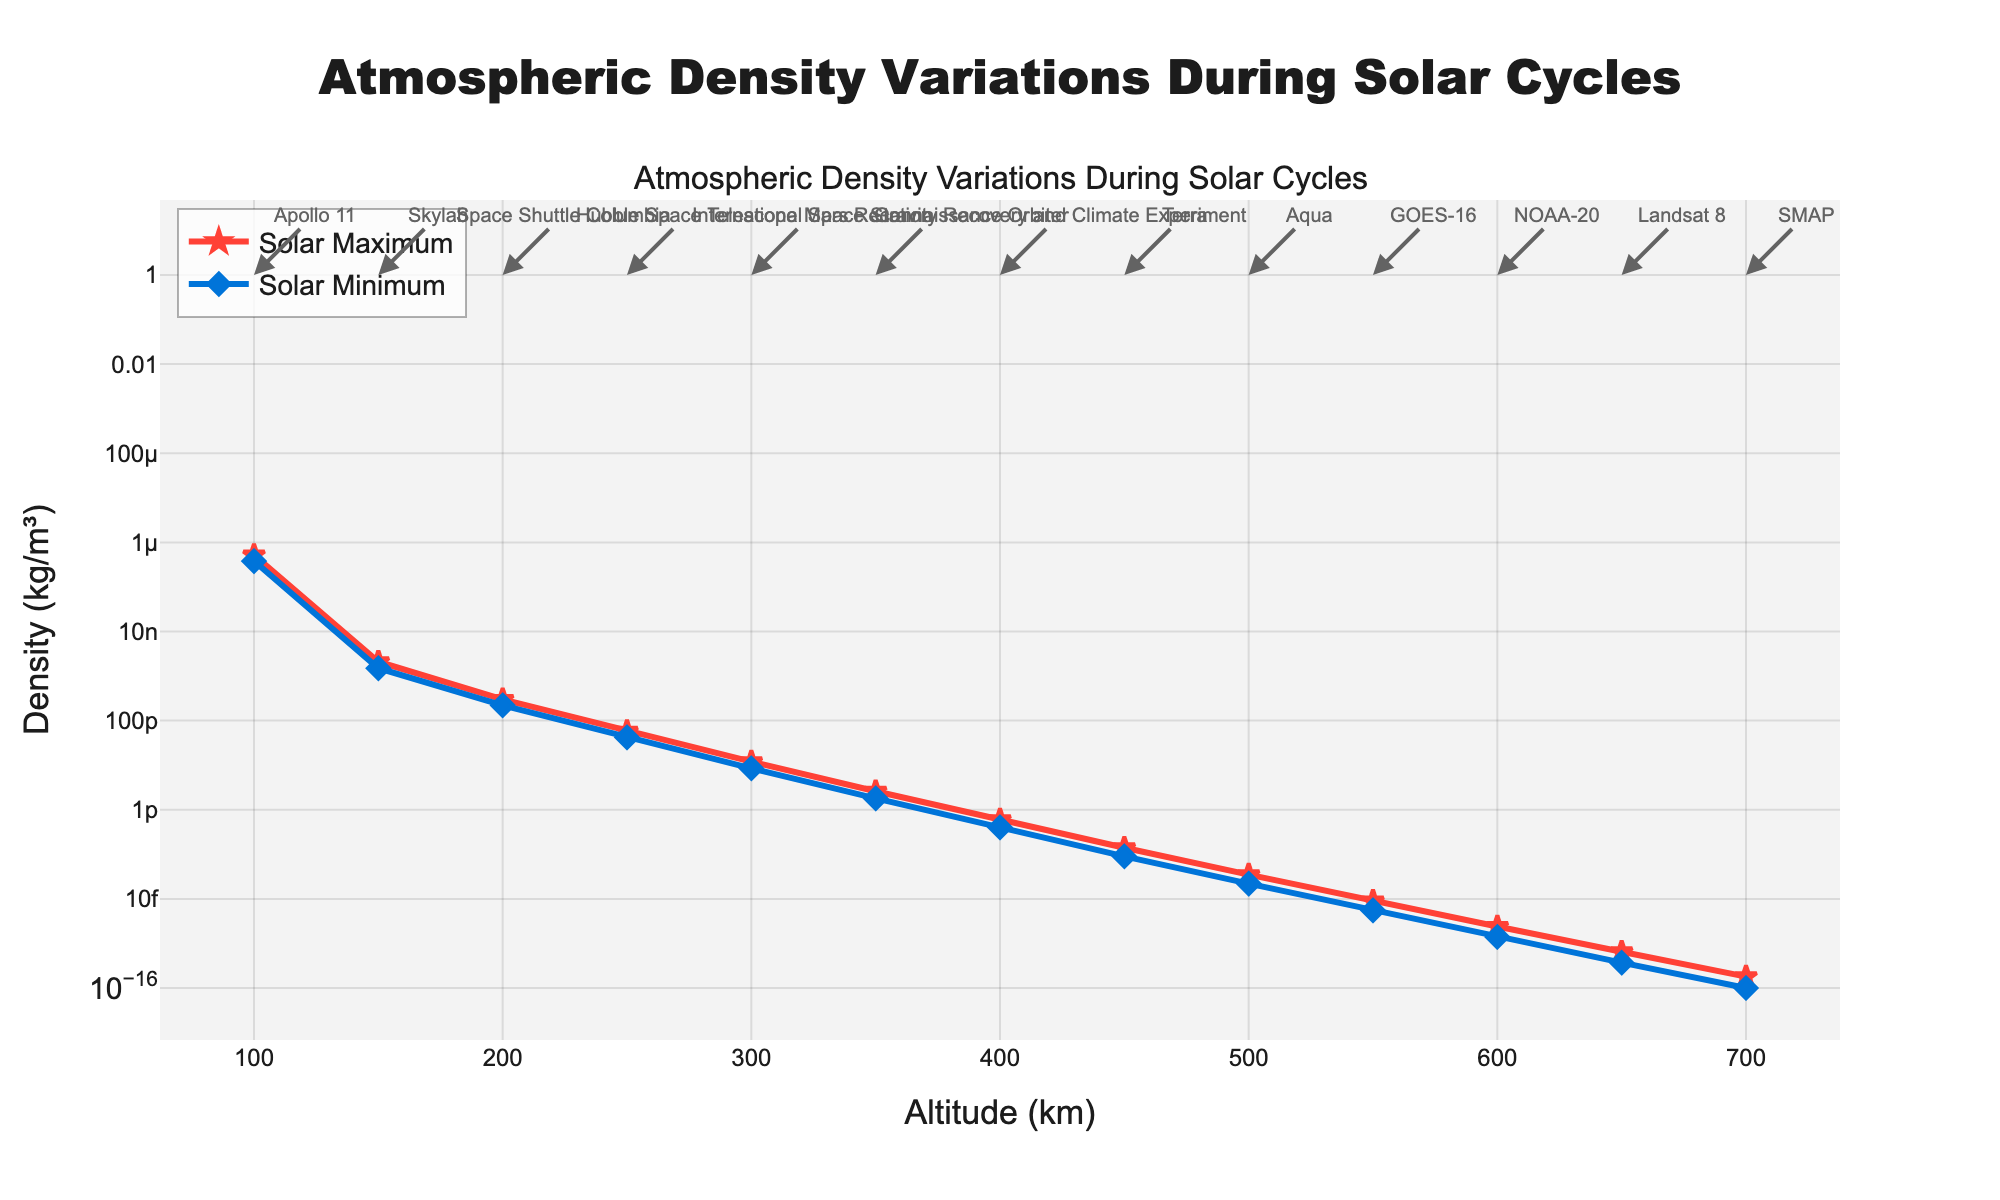What is the altitudes at which we have data for both solar maximum and solar minimum densities? By observing the x-axis of the chart, identify each point where density values are plotted for both solar maximum and minimum. These points correspond to the altitudes where data is available for both conditions.
Answer: 100, 150, 200, 250, 300, 350, 400, 450, 500, 550, 600, 650, 700 How does the density at 100 km vary between solar maximum and minimum? Locate the point on the x-axis corresponding to an altitude of 100 km, then compare the values of the lines for solar maximum and solar minimum densities.
Answer: The solar maximum density is higher than the solar minimum density Which mission is associated with the density measurement at 300 km? Look for the annotation or label on the plot at the point corresponding to 300 km altitude.
Answer: International Space Station How does atmospheric density overall change with altitude during a solar maximum? Observe the trend of the red line (solar maximum) from the lowest altitude (100 km) to the highest altitude (700 km) to see how it changes.
Answer: It decreases with increasing altitude At what altitude does the solar maximum density first fall below 1.00E-10 kg/m³? Examine the red line representing solar maximum density and identify the altitude at which the density first falls below 1.00E-10 kg/m³.
Answer: 200 km What is the difference in atmospheric density between 100 km and 200 km during a solar minimum? Compare the densities at 100 km and 200 km on the blue line (solar minimum), then subtract the 200 km value from the 100 km value.
Answer: 1.60E-07 kg/m³ Which mission has the smallest difference in density between solar maximum and minimum at its designated altitude? Compare the differences between solar maximum and minimum densities for each mission's designated altitude, and identify the smallest difference.
Answer: SMAP Is the reduction in atmospheric density from 100 km to 700 km greater during solar maximum or solar minimum? Calculate or observe the overall reduction in density between 100 km and 700 km for both solar maximum and solar minimum lines, then compare the two reductions.
Answer: Greater during solar maximum What is the density ratio of solar maximum to solar minimum at 550 km? Identify the densities at 550 km for both solar maximum and minimum (red and blue lines), then calculate the ratio by dividing the solar maximum density by the solar minimum density.
Answer: Approximately 1.64 